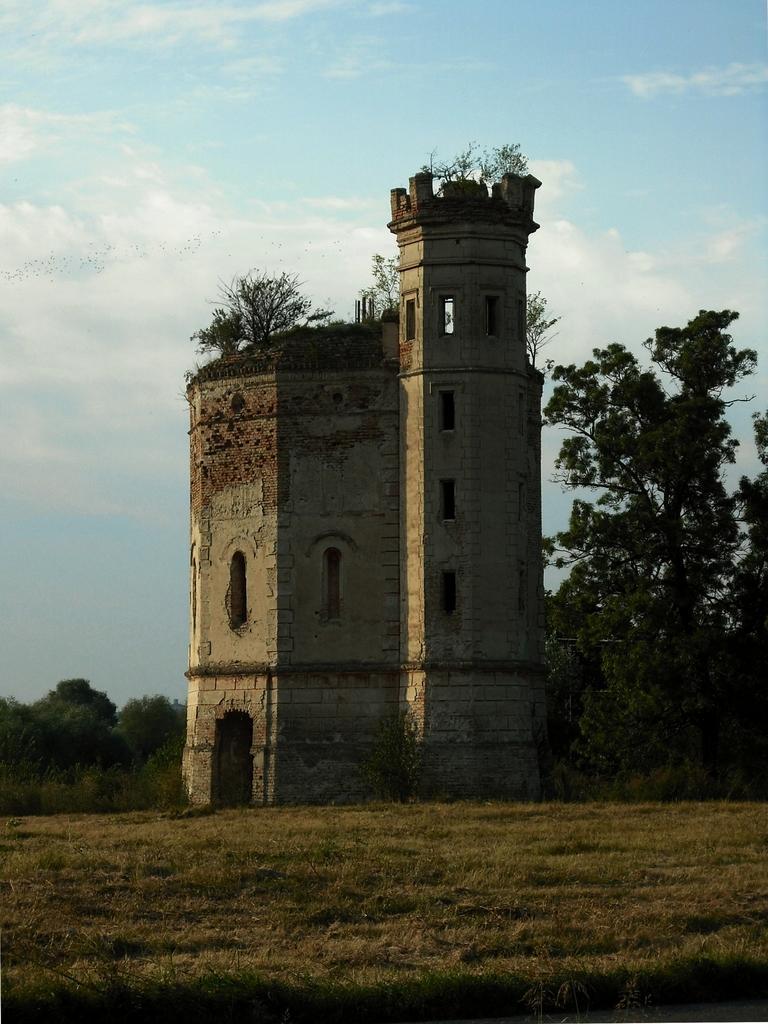How would you summarize this image in a sentence or two? In this image, we can see a fort with walls and windows. Here we can see plants, trees and grass. Background there is a sky. 